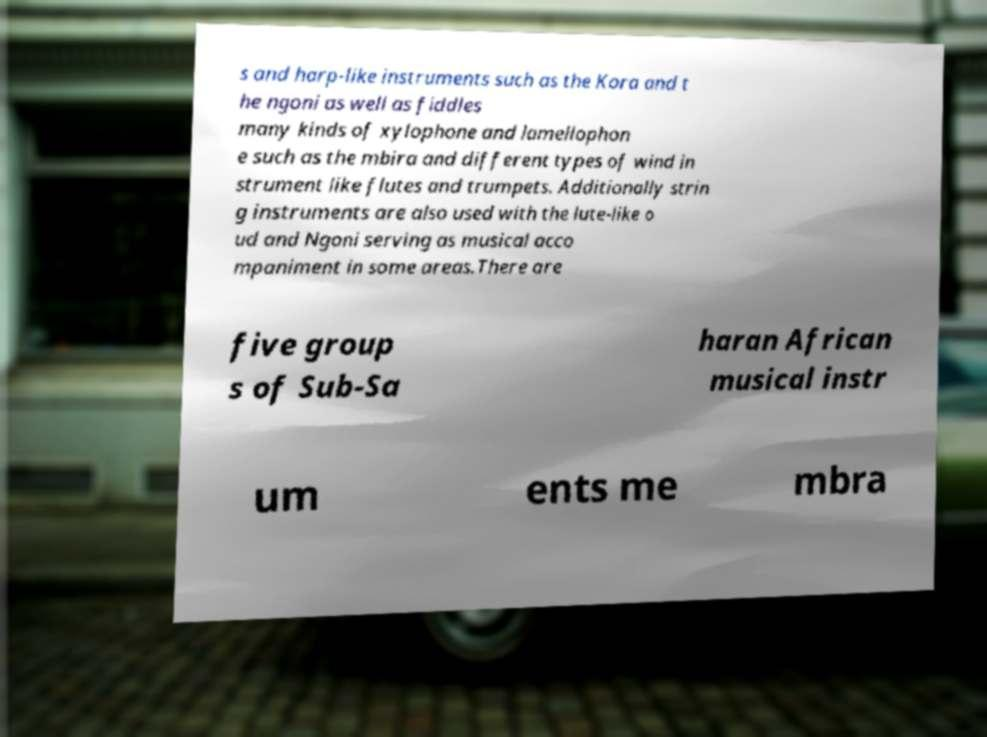Can you read and provide the text displayed in the image?This photo seems to have some interesting text. Can you extract and type it out for me? s and harp-like instruments such as the Kora and t he ngoni as well as fiddles many kinds of xylophone and lamellophon e such as the mbira and different types of wind in strument like flutes and trumpets. Additionally strin g instruments are also used with the lute-like o ud and Ngoni serving as musical acco mpaniment in some areas.There are five group s of Sub-Sa haran African musical instr um ents me mbra 